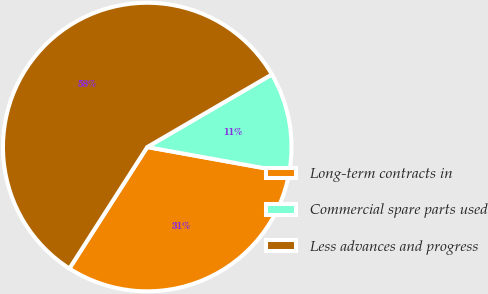Convert chart to OTSL. <chart><loc_0><loc_0><loc_500><loc_500><pie_chart><fcel>Long-term contracts in<fcel>Commercial spare parts used<fcel>Less advances and progress<nl><fcel>31.23%<fcel>11.24%<fcel>57.53%<nl></chart> 